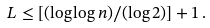Convert formula to latex. <formula><loc_0><loc_0><loc_500><loc_500>L \leq [ ( \log \log n ) / ( \log 2 ) ] + 1 \, .</formula> 